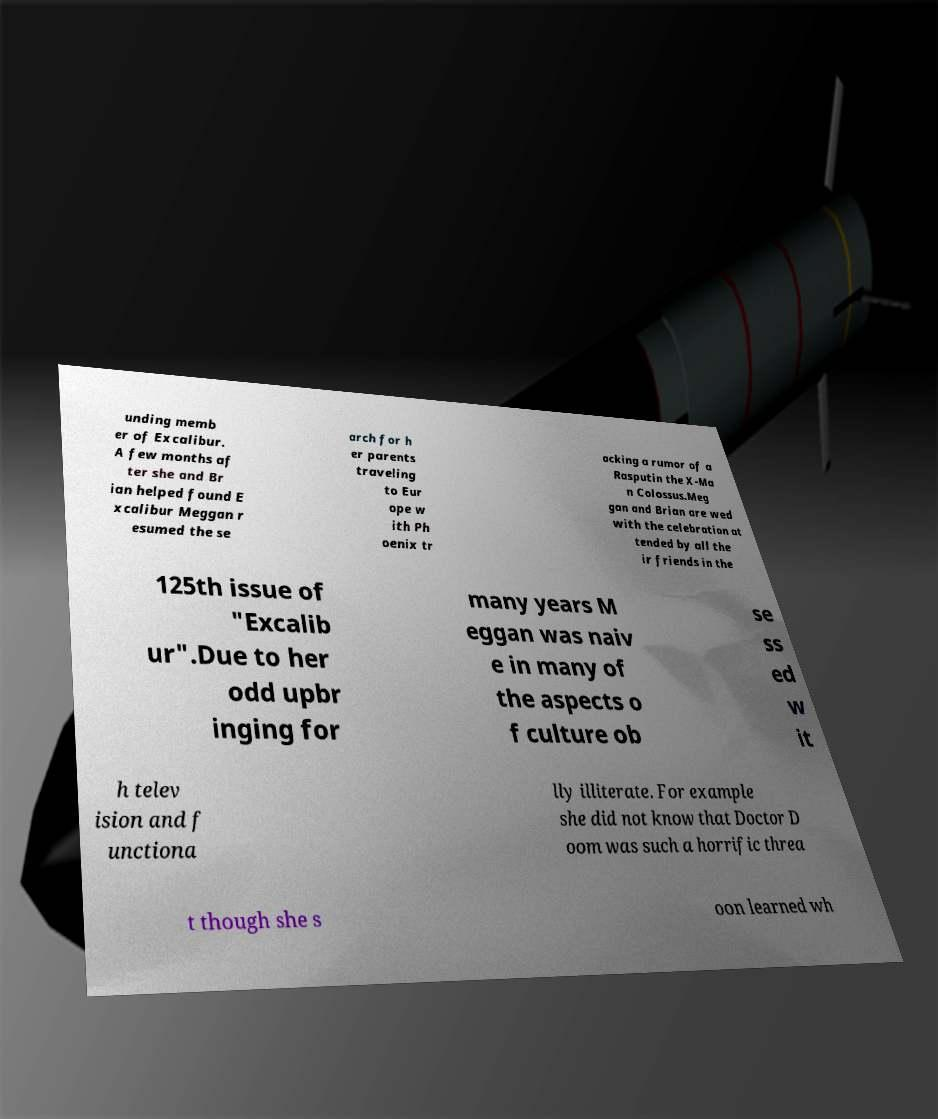Can you accurately transcribe the text from the provided image for me? unding memb er of Excalibur. A few months af ter she and Br ian helped found E xcalibur Meggan r esumed the se arch for h er parents traveling to Eur ope w ith Ph oenix tr acking a rumor of a Rasputin the X-Ma n Colossus.Meg gan and Brian are wed with the celebration at tended by all the ir friends in the 125th issue of "Excalib ur".Due to her odd upbr inging for many years M eggan was naiv e in many of the aspects o f culture ob se ss ed w it h telev ision and f unctiona lly illiterate. For example she did not know that Doctor D oom was such a horrific threa t though she s oon learned wh 